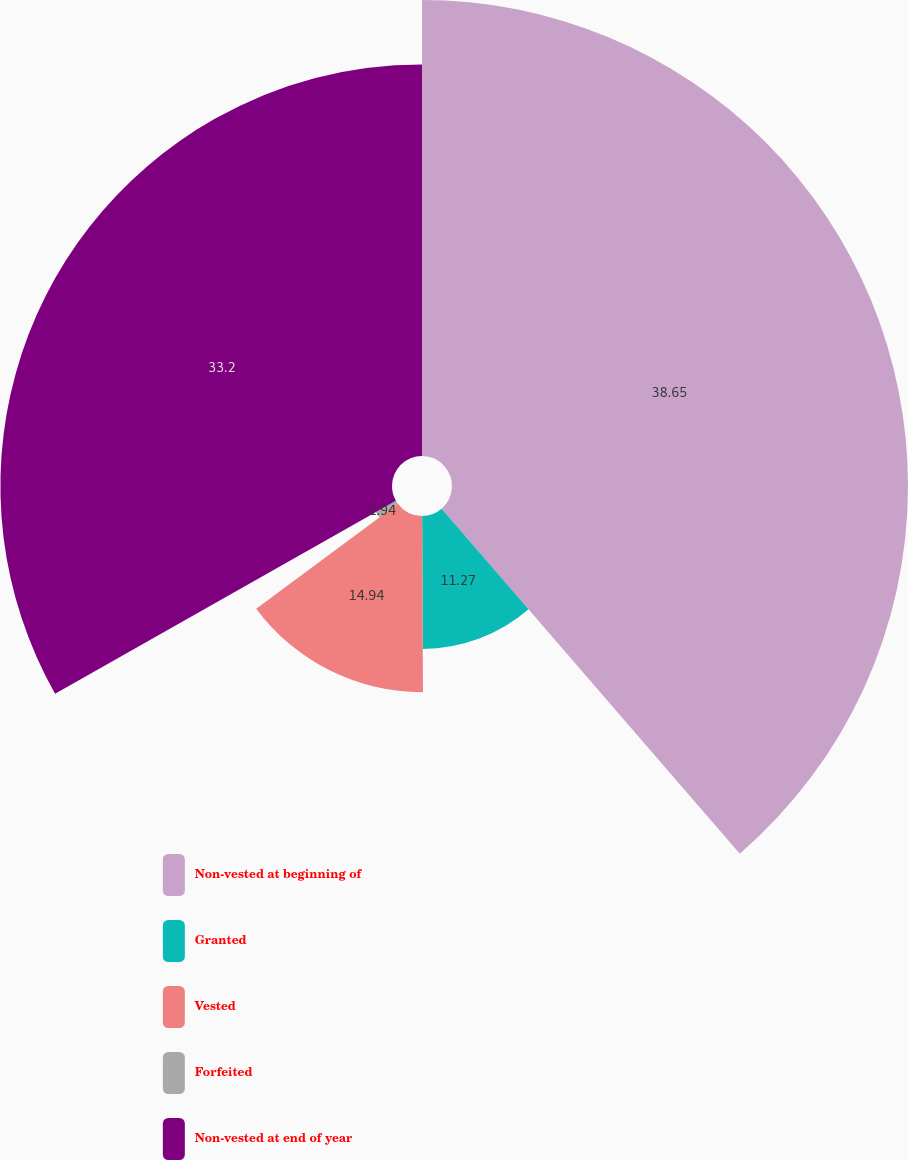Convert chart. <chart><loc_0><loc_0><loc_500><loc_500><pie_chart><fcel>Non-vested at beginning of<fcel>Granted<fcel>Vested<fcel>Forfeited<fcel>Non-vested at end of year<nl><fcel>38.66%<fcel>11.27%<fcel>14.94%<fcel>1.94%<fcel>33.2%<nl></chart> 